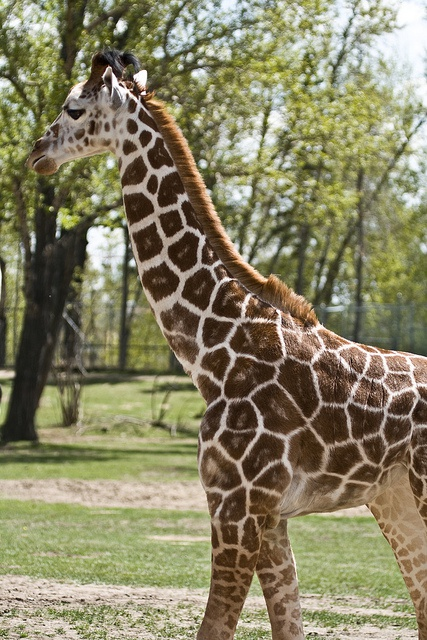Describe the objects in this image and their specific colors. I can see a giraffe in olive, black, maroon, and darkgray tones in this image. 